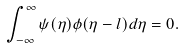<formula> <loc_0><loc_0><loc_500><loc_500>\int _ { - \infty } ^ { \infty } \psi ( \eta ) \phi ( \eta - l ) d \eta = 0 .</formula> 